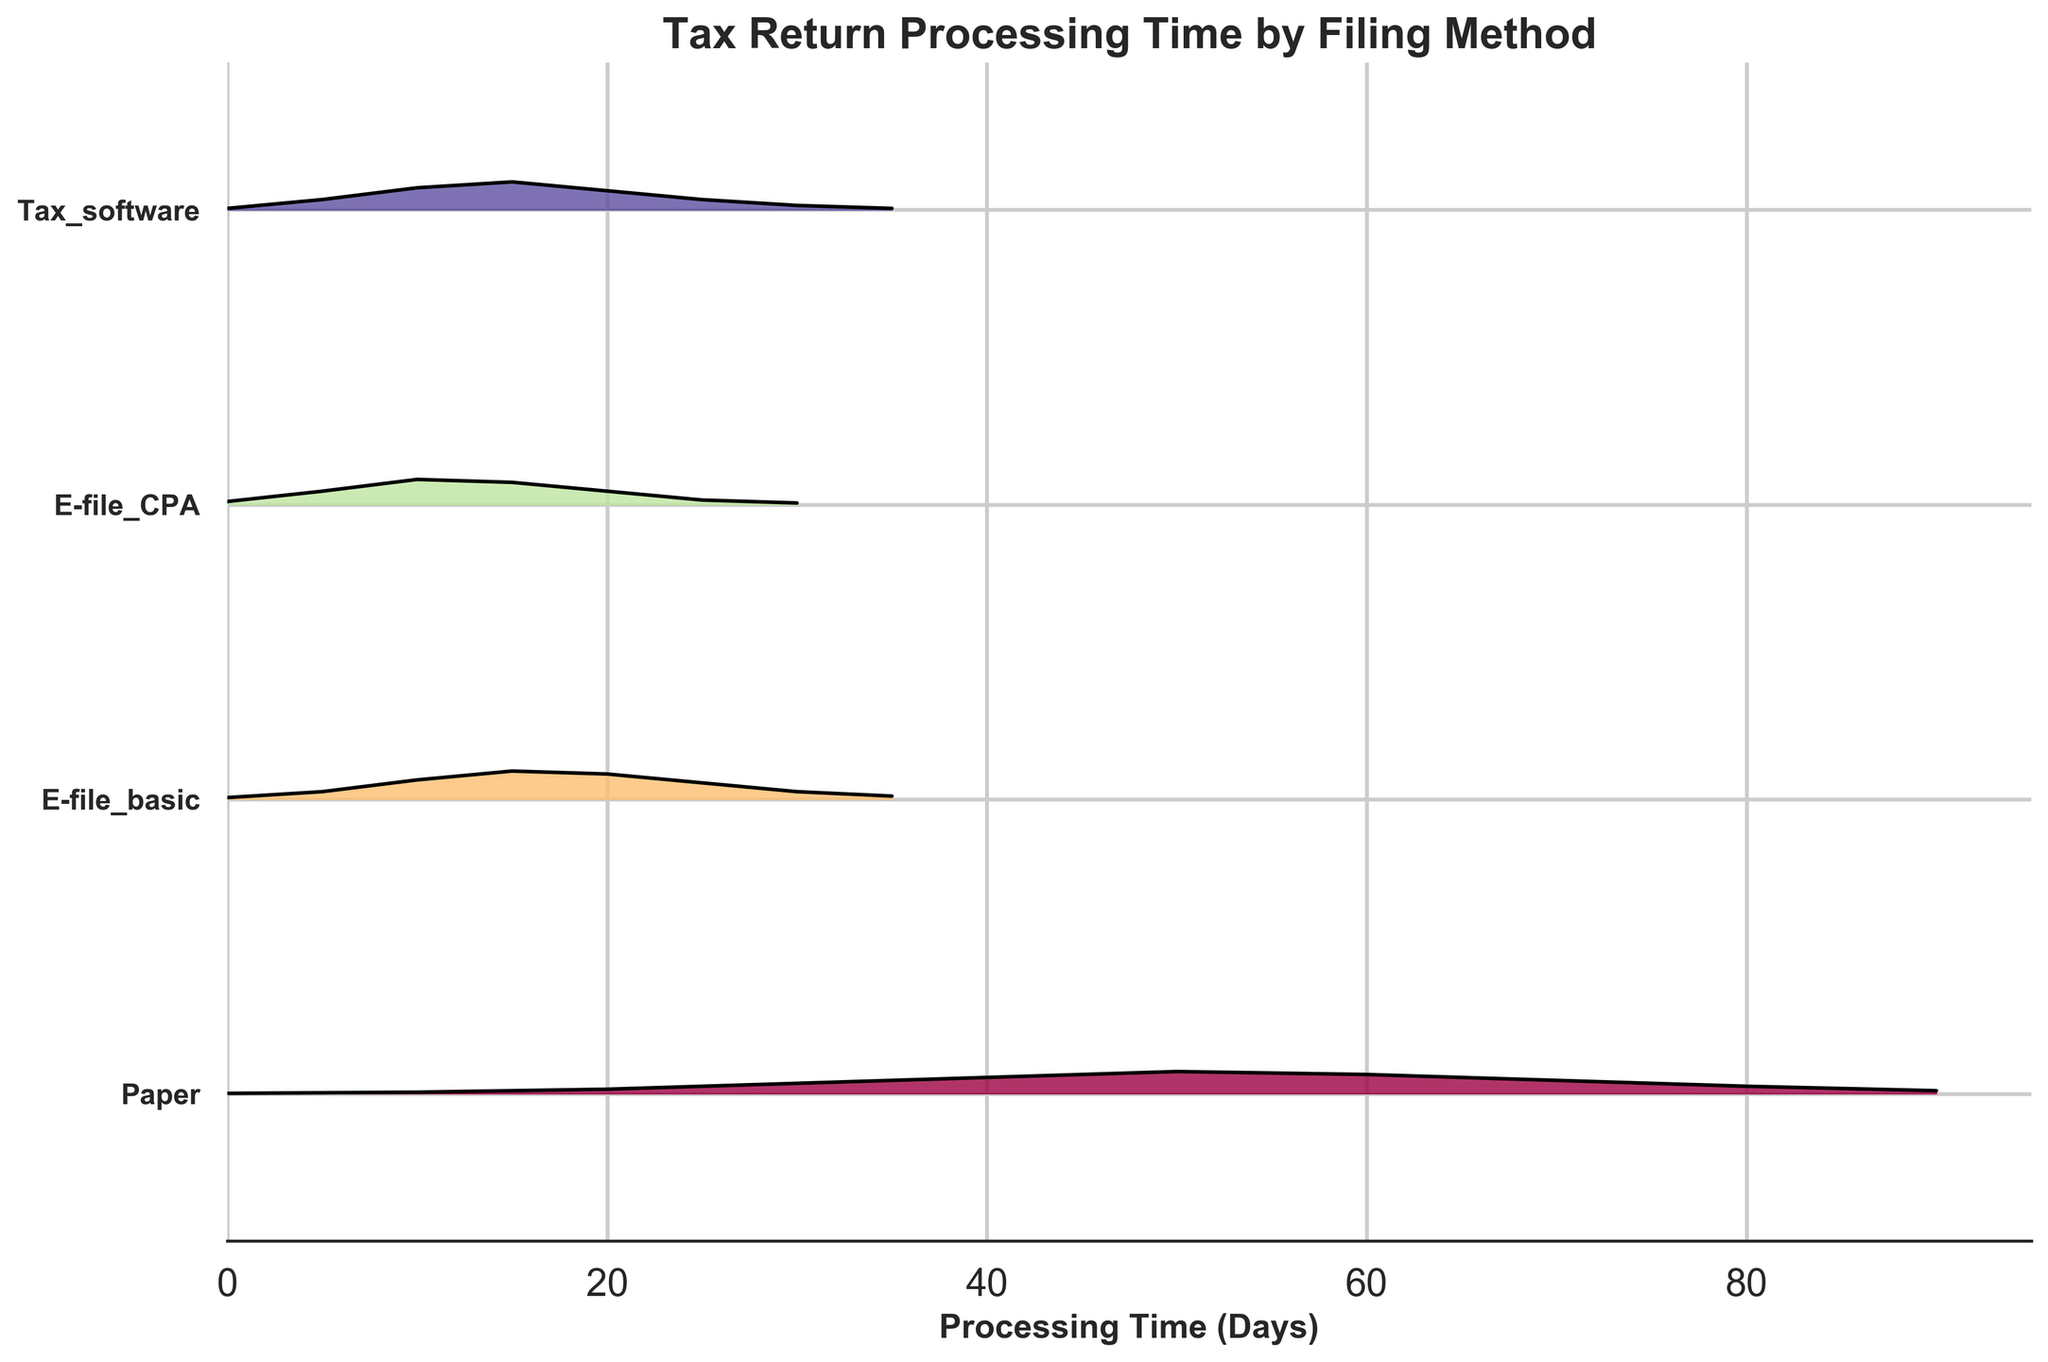What's the title of the figure? The title is found at the top of the chart and usually summarizes the main subject of the plot.
Answer: Tax Return Processing Time by Filing Method What is the range of the x-axis? The x-axis represents the processing time in days, and the range is shown at the bottom of the plot. The chart starts from 0 days and ends at 95 days.
Answer: 0 to 95 How many filing methods are compared in the plot? By counting the unique labels along the y-axis, which represent different filing methods, we can determine the number of methods compared.
Answer: 4 Which filing method has the highest peak density and roughly at what day? By inspecting the ridgeline plot, we can identify which curve has the highest peak (the tallest curve). The E-file_basic method has the highest density, peaking around 15 days.
Answer: E-file_basic, 15 Which filing method shows the longest processing times? By observing the farthest right point in the figure for each method, we can see that the Paper method extends closest to 90 days, indicating longer processing times.
Answer: Paper For E-file_CPA, what is the density around 15 days? We need to examine the height of the E-file_CPA curve at the 15-day mark to determine the density value.
Answer: 0.075 Compare the processing times for E-file_basic and E-file_CPA; which one generally processes faster? By comparing the peak concentrations of the two methods, we can see that E-file_basic peaks around 15 days and E-file_CPA peaks between 10-15 days.
Answer: E-file_CPA What is the general trend for Tax_software processing time? The Tax_software method shows a gradual rise to a peak around 15 days and then steadily declines.
Answer: Peaks at 15 days and declines Among the four methods, which one has the narrowest density distribution? The narrowest distribution can be identified by the ridgeline plot where the density concentration is tightest around the peak. E-file_CPA displays the narrowest distribution around its peak.
Answer: E-file_CPA Determine the difference in peak processing days between Paper and E-file_basic methods. Paper peaks roughly around 50-60 days, while E-file_basic peaks around 15 days. The difference in peak days can be calculated as 50 (Paper) - 15 (E-file_basic) = 35 days.
Answer: 35 days 